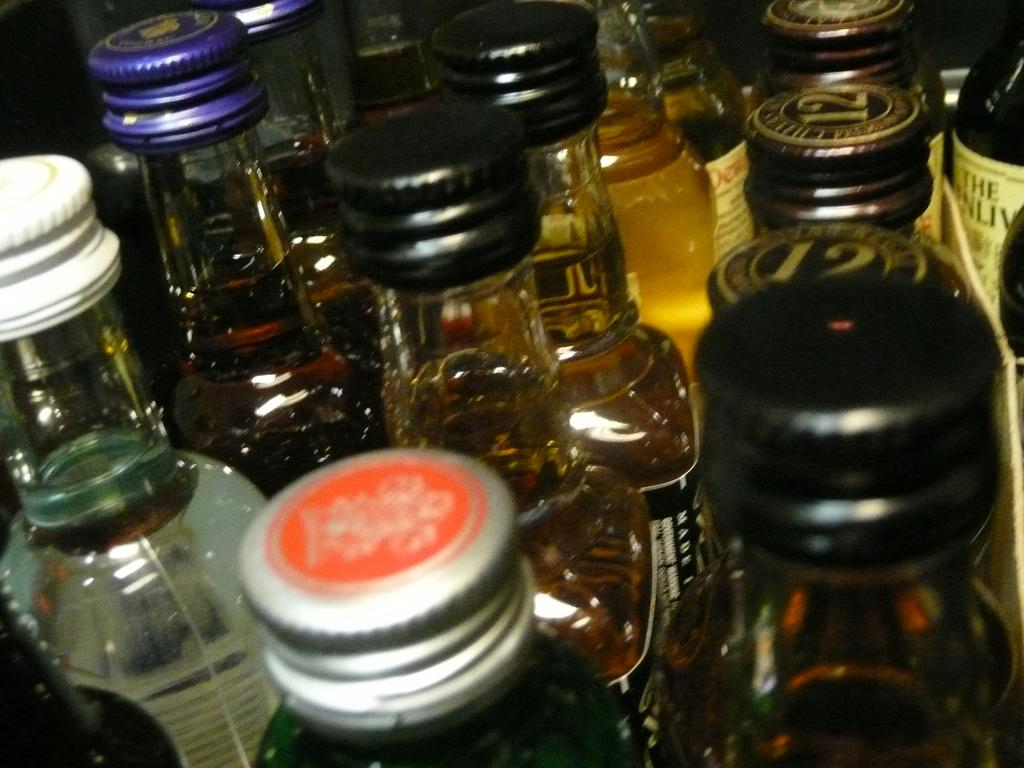What type of beverage containers are present in the image? There are beer bottles in the image. How are the beer bottles arranged? The beer bottles are arranged in a straight line. What distinguishing feature can be seen on the beer bottles? There are closed knobs of different colors on the beer bottles. What type of vegetable is growing in the image? There is no vegetable present in the image; it features beer bottles arranged in a straight line with closed knobs of different colors. 